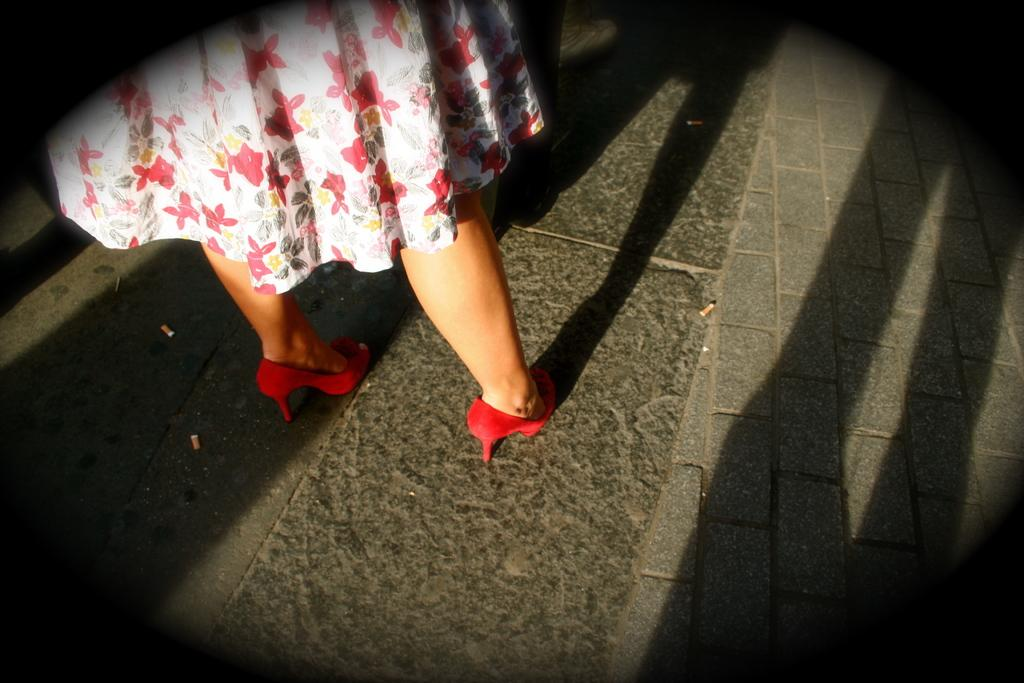What is the main subject of the image? There is a person standing in the image. What can be observed on the ground in the image? There are shadows on the ground in the image. What type of wool is used to make the scarf worn by the person in the image? There is no scarf visible in the image, so it is not possible to determine the type of wool used. 